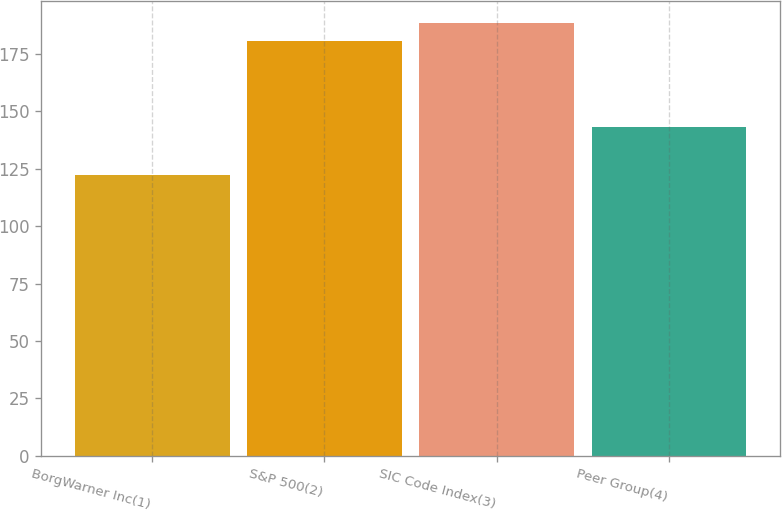Convert chart. <chart><loc_0><loc_0><loc_500><loc_500><bar_chart><fcel>BorgWarner Inc(1)<fcel>S&P 500(2)<fcel>SIC Code Index(3)<fcel>Peer Group(4)<nl><fcel>122.38<fcel>180.75<fcel>188.51<fcel>143.08<nl></chart> 